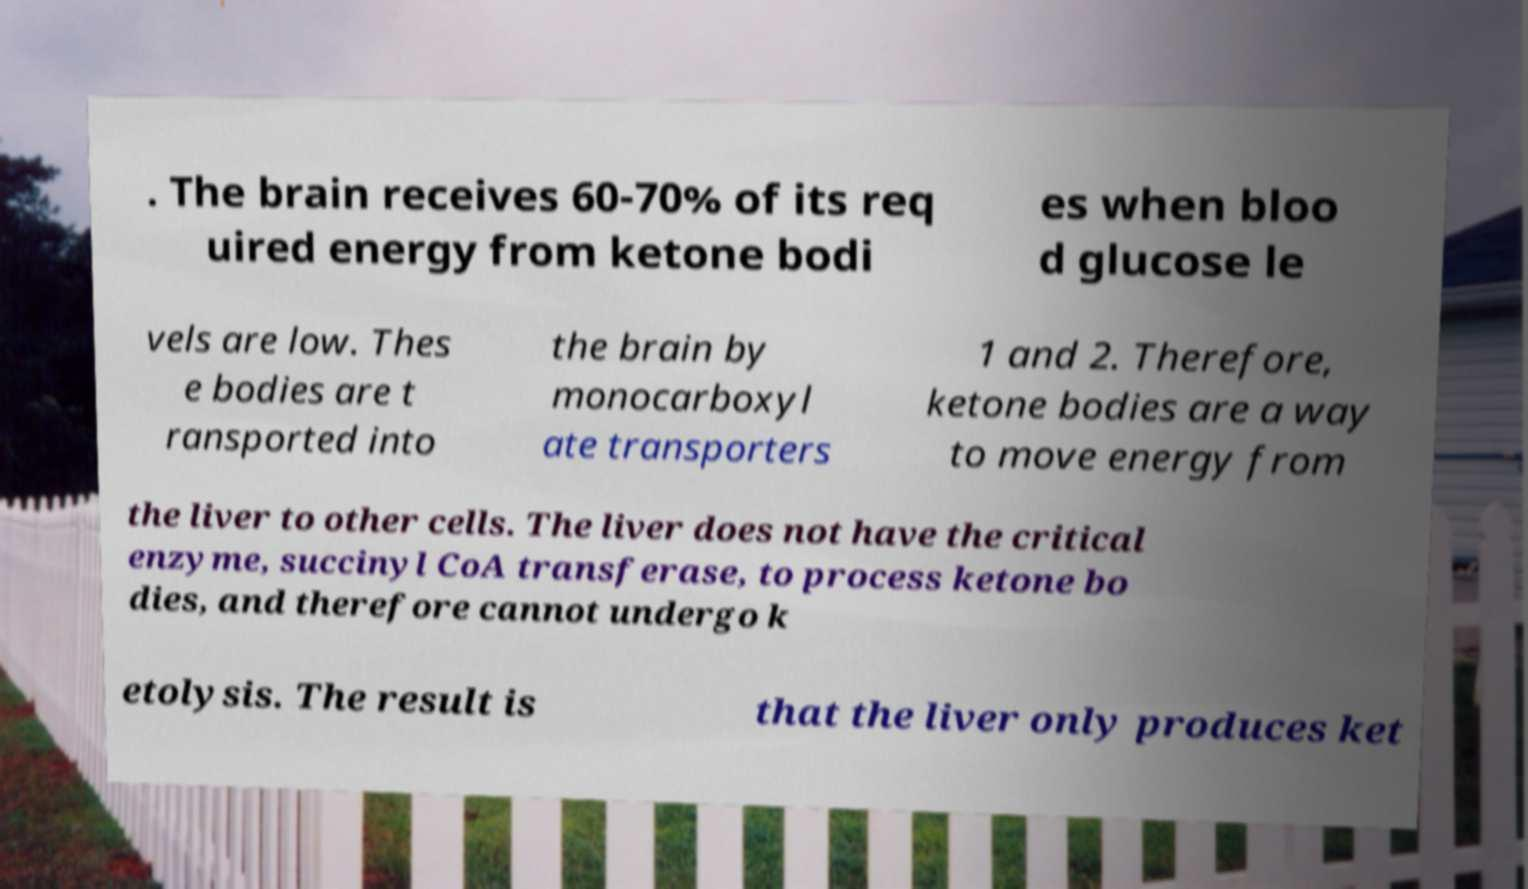Can you accurately transcribe the text from the provided image for me? . The brain receives 60-70% of its req uired energy from ketone bodi es when bloo d glucose le vels are low. Thes e bodies are t ransported into the brain by monocarboxyl ate transporters 1 and 2. Therefore, ketone bodies are a way to move energy from the liver to other cells. The liver does not have the critical enzyme, succinyl CoA transferase, to process ketone bo dies, and therefore cannot undergo k etolysis. The result is that the liver only produces ket 